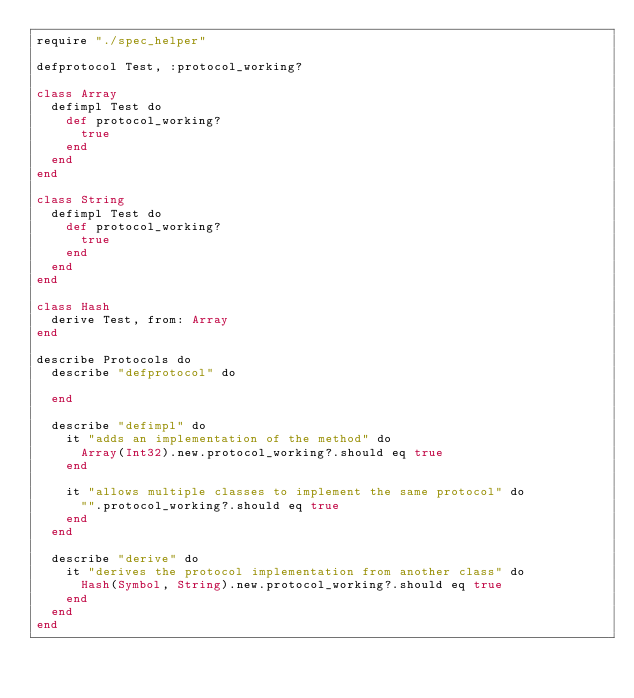Convert code to text. <code><loc_0><loc_0><loc_500><loc_500><_Crystal_>require "./spec_helper"

defprotocol Test, :protocol_working?

class Array
  defimpl Test do
    def protocol_working?
      true
    end
  end
end

class String
  defimpl Test do
    def protocol_working?
      true
    end
  end
end

class Hash
  derive Test, from: Array
end

describe Protocols do
  describe "defprotocol" do

  end

  describe "defimpl" do
    it "adds an implementation of the method" do
      Array(Int32).new.protocol_working?.should eq true
    end

    it "allows multiple classes to implement the same protocol" do
      "".protocol_working?.should eq true
    end
  end

  describe "derive" do
    it "derives the protocol implementation from another class" do
      Hash(Symbol, String).new.protocol_working?.should eq true
    end
  end
end
</code> 